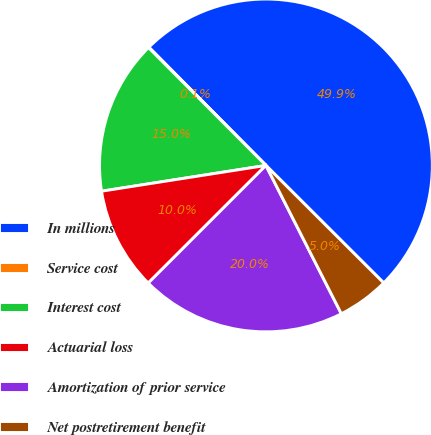Convert chart to OTSL. <chart><loc_0><loc_0><loc_500><loc_500><pie_chart><fcel>In millions<fcel>Service cost<fcel>Interest cost<fcel>Actuarial loss<fcel>Amortization of prior service<fcel>Net postretirement benefit<nl><fcel>49.9%<fcel>0.05%<fcel>15.0%<fcel>10.02%<fcel>19.99%<fcel>5.03%<nl></chart> 